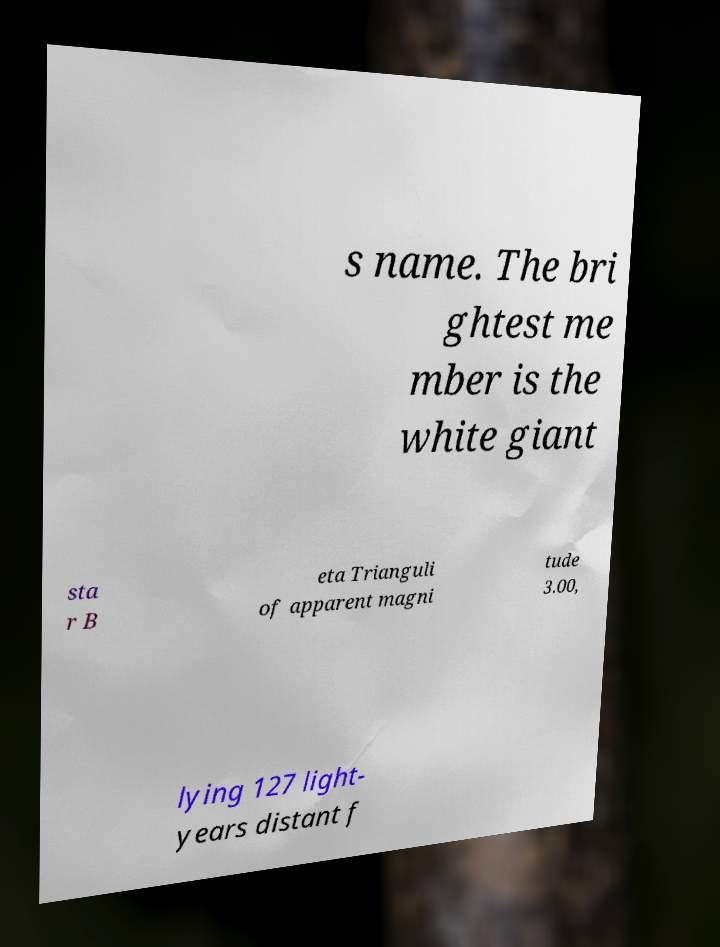Could you extract and type out the text from this image? s name. The bri ghtest me mber is the white giant sta r B eta Trianguli of apparent magni tude 3.00, lying 127 light- years distant f 